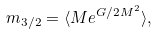Convert formula to latex. <formula><loc_0><loc_0><loc_500><loc_500>m _ { 3 / 2 } = \langle M e ^ { G / 2 M ^ { 2 } } \rangle ,</formula> 